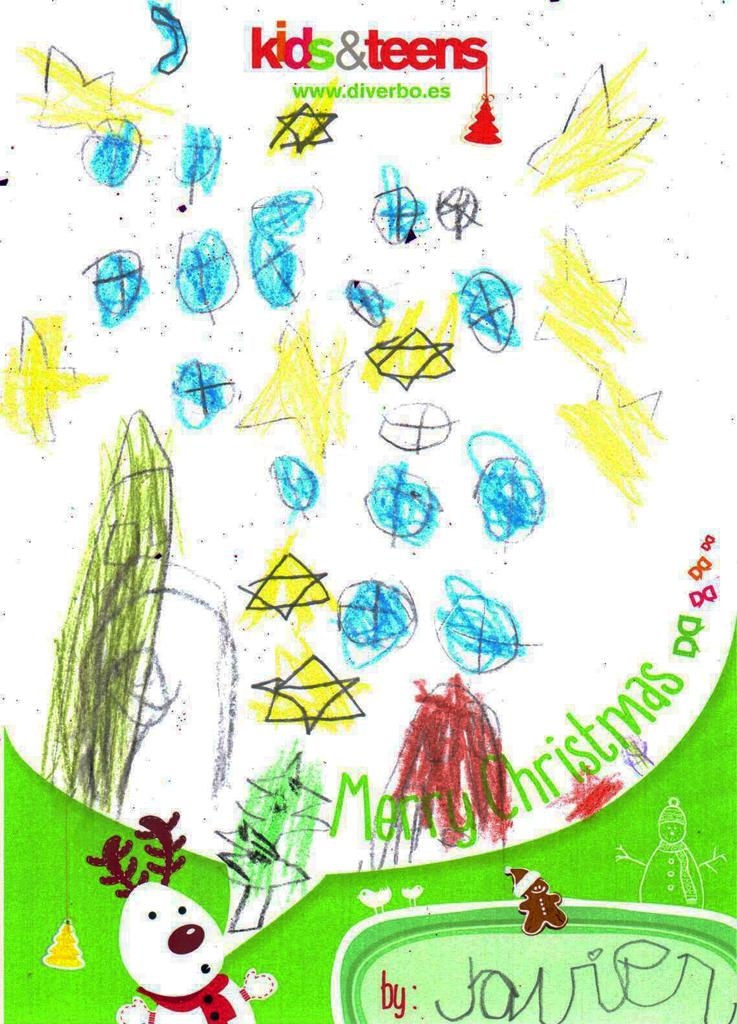What is the main subject of the image? The main subject of the image is a painting. What is featured on the painting? There is text written on the painting. What is the purpose of the painting in the image? The provided facts do not mention the purpose of the painting, so it cannot be determined from the image. Where is the painting located in relation to the north in the image? The provided facts do not mention the location of the painting in relation to the north, so it cannot be determined from the image. 